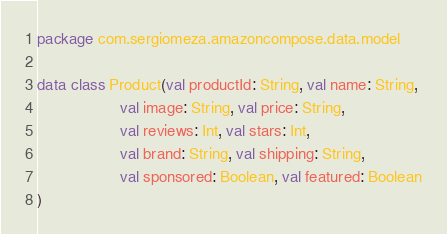<code> <loc_0><loc_0><loc_500><loc_500><_Kotlin_>package com.sergiomeza.amazoncompose.data.model

data class Product(val productId: String, val name: String,
                   val image: String, val price: String,
                   val reviews: Int, val stars: Int,
                   val brand: String, val shipping: String,
                   val sponsored: Boolean, val featured: Boolean
)
</code> 